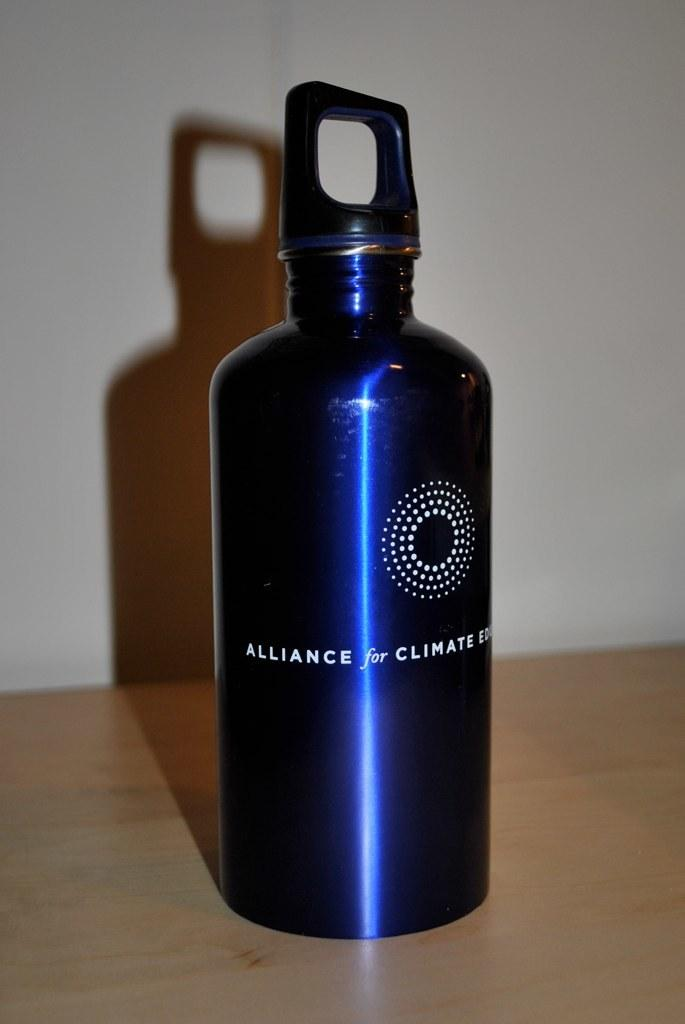<image>
Offer a succinct explanation of the picture presented. A blue metal water bottle is labeled with the Alliance for Climate Education. 